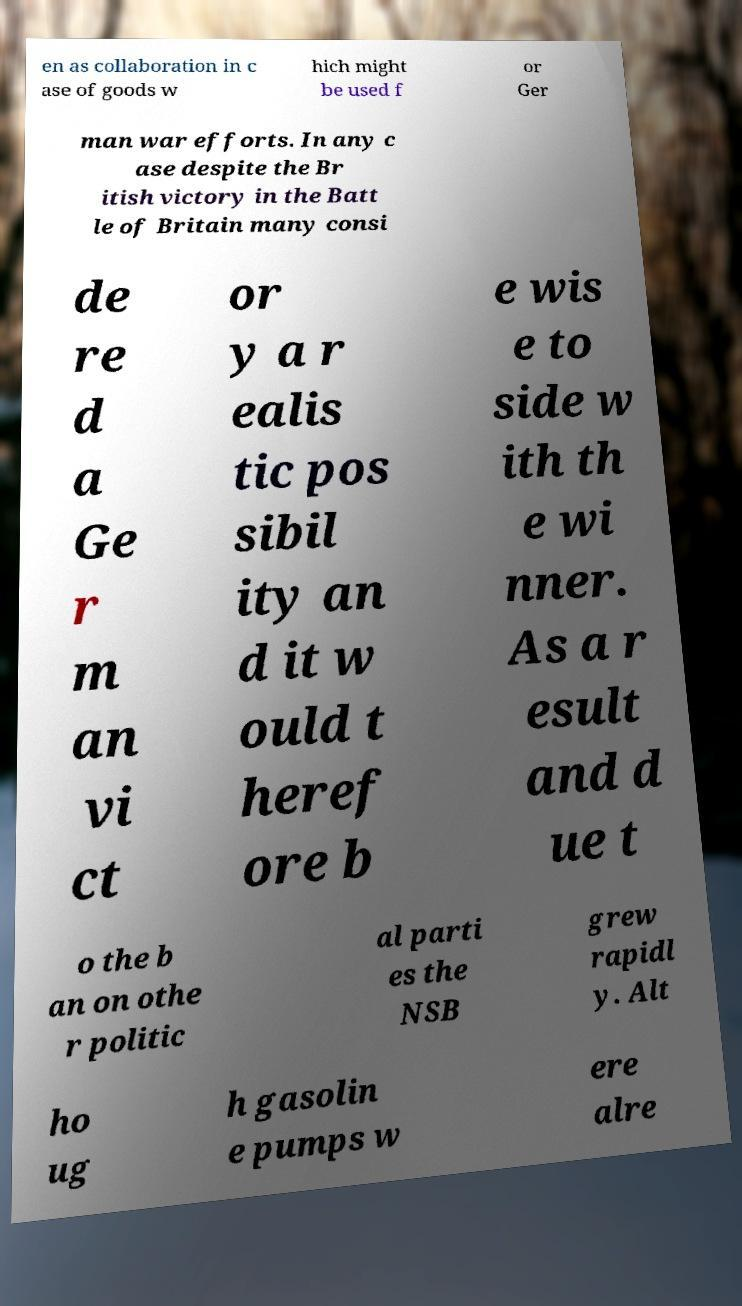Can you read and provide the text displayed in the image?This photo seems to have some interesting text. Can you extract and type it out for me? en as collaboration in c ase of goods w hich might be used f or Ger man war efforts. In any c ase despite the Br itish victory in the Batt le of Britain many consi de re d a Ge r m an vi ct or y a r ealis tic pos sibil ity an d it w ould t heref ore b e wis e to side w ith th e wi nner. As a r esult and d ue t o the b an on othe r politic al parti es the NSB grew rapidl y. Alt ho ug h gasolin e pumps w ere alre 